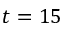Convert formula to latex. <formula><loc_0><loc_0><loc_500><loc_500>t = 1 5</formula> 